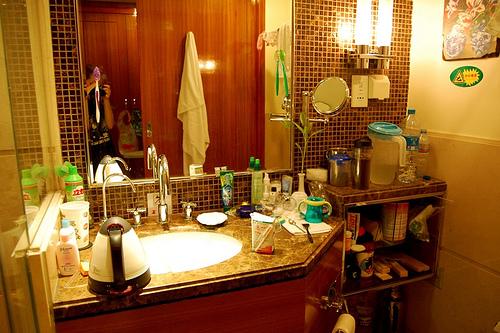Is the room cluttered?
Keep it brief. Yes. Where is the pitcher of water?
Keep it brief. Right. What room is this?
Be succinct. Bathroom. 